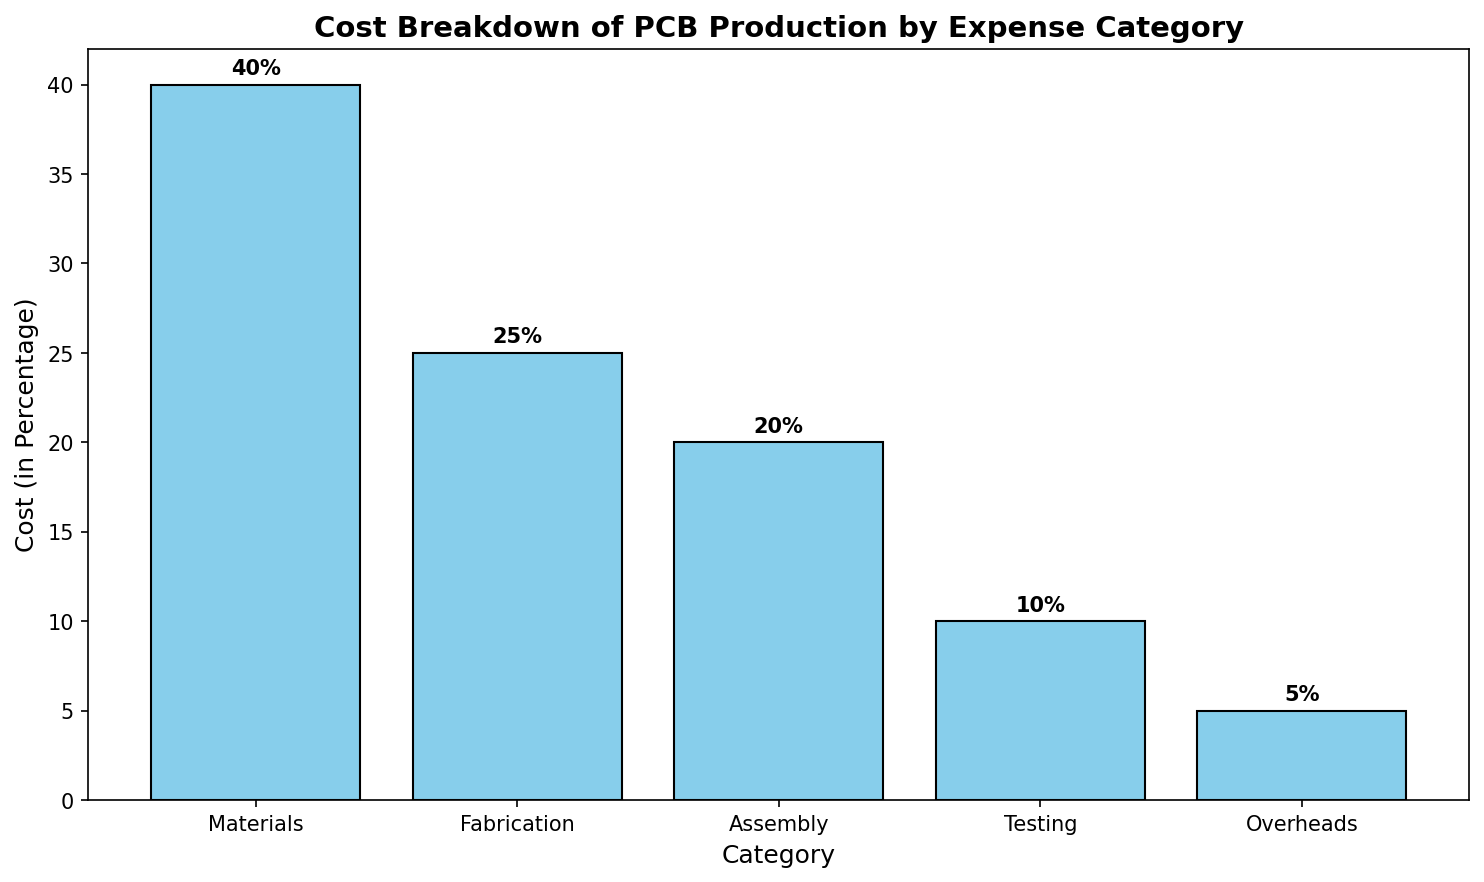Which category has the highest cost? By looking at the figure, we can see that the tallest bar represents the category with the highest cost. In this case, it is the 'Materials' category.
Answer: Materials How much more does Assembly cost compared to Overheads? To find out how much more Assembly costs compared to Overheads, we look at their respective bar heights. Assembly is 20% and Overheads is 5%. The difference is 20% - 5% = 15%.
Answer: 15% What is the total cost of Fabrication and Testing together? To find the total cost of Fabrication and Testing together, we sum their values. Fabrication is 25% and Testing is 10%. Thus, 25% + 10% = 35%.
Answer: 35% Which categories have costs equal to or less than 20%? By examining the height of the bars, we can see that the categories with costs equal to or less than 20% are Assembly (20%), Testing (10%), and Overheads (5%).
Answer: Assembly, Testing, Overheads What is the average cost of all categories? To find the average cost, sum the costs of all categories and divide by the number of categories. The sum is 40% + 25% + 20% + 10% + 5% = 100%. There are 5 categories. So, average cost is 100% / 5 = 20%.
Answer: 20% By how much does the cost of Materials exceed the cost of Testing? The cost of Materials is 40%, and the cost of Testing is 10%. To find how much Materials exceed Testing, we subtract Testing from Materials. So, 40% - 10% = 30%.
Answer: 30% Which category has the lowest cost and what is its value? By looking at the figure, we can see that the shortest bar represents the category with the lowest cost. In this case, it is the 'Overheads' category with a cost of 5%.
Answer: Overheads, 5% If Fabrication and Assembly costs are combined into a single category, what would be the new highest cost category? Combining Fabrication (25%) and Assembly (20%) gives a new category with a cost of 45%. Comparing this with other categories: Materials (40%), Testing (10%), and Overheads (5%), we see that the new combined category would become the highest cost category.
Answer: Combined Fabrication and Assembly By what percentage is the cost of Fabrication less than the cost of Materials? The cost of Fabrication is 25% and the cost of Materials is 40%. To find the percentage by which Fabrication is less than Materials, subtract Fabrication from Materials then divide by Materials, and multiply by 100. So, (40% - 25%) / 40% * 100 = 37.5%.
Answer: 37.5% 